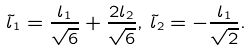Convert formula to latex. <formula><loc_0><loc_0><loc_500><loc_500>\tilde { l } _ { 1 } = \frac { l _ { 1 } } { \sqrt { 6 } } + \frac { 2 l _ { 2 } } { \sqrt { 6 } } , \, \tilde { l } _ { 2 } = - \frac { l _ { 1 } } { \sqrt { 2 } } .</formula> 